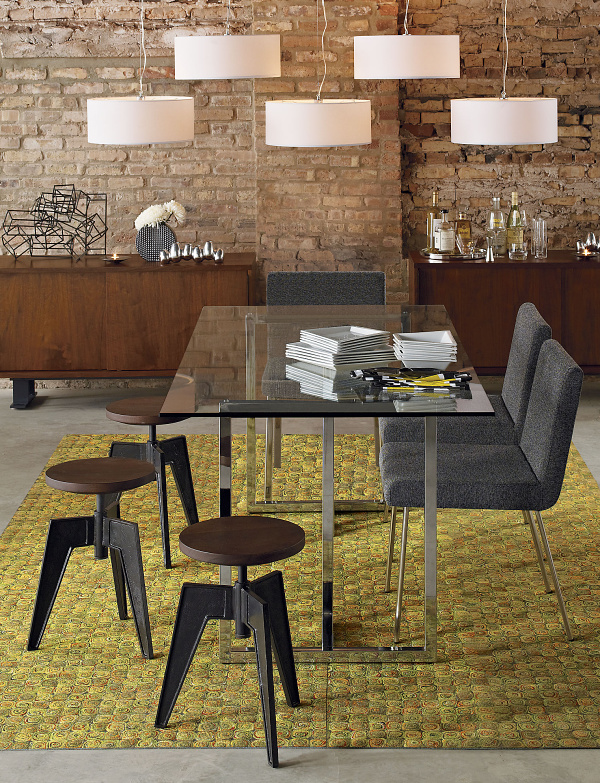How many dining tables are there in the image? There is one dining table in the image. It has a transparent glass top and metal frame, reflecting a contemporary design. The table is accompanied by matching stools and is set against an exposed brick wall, contributing to an overall industrial-chic aesthetic. 